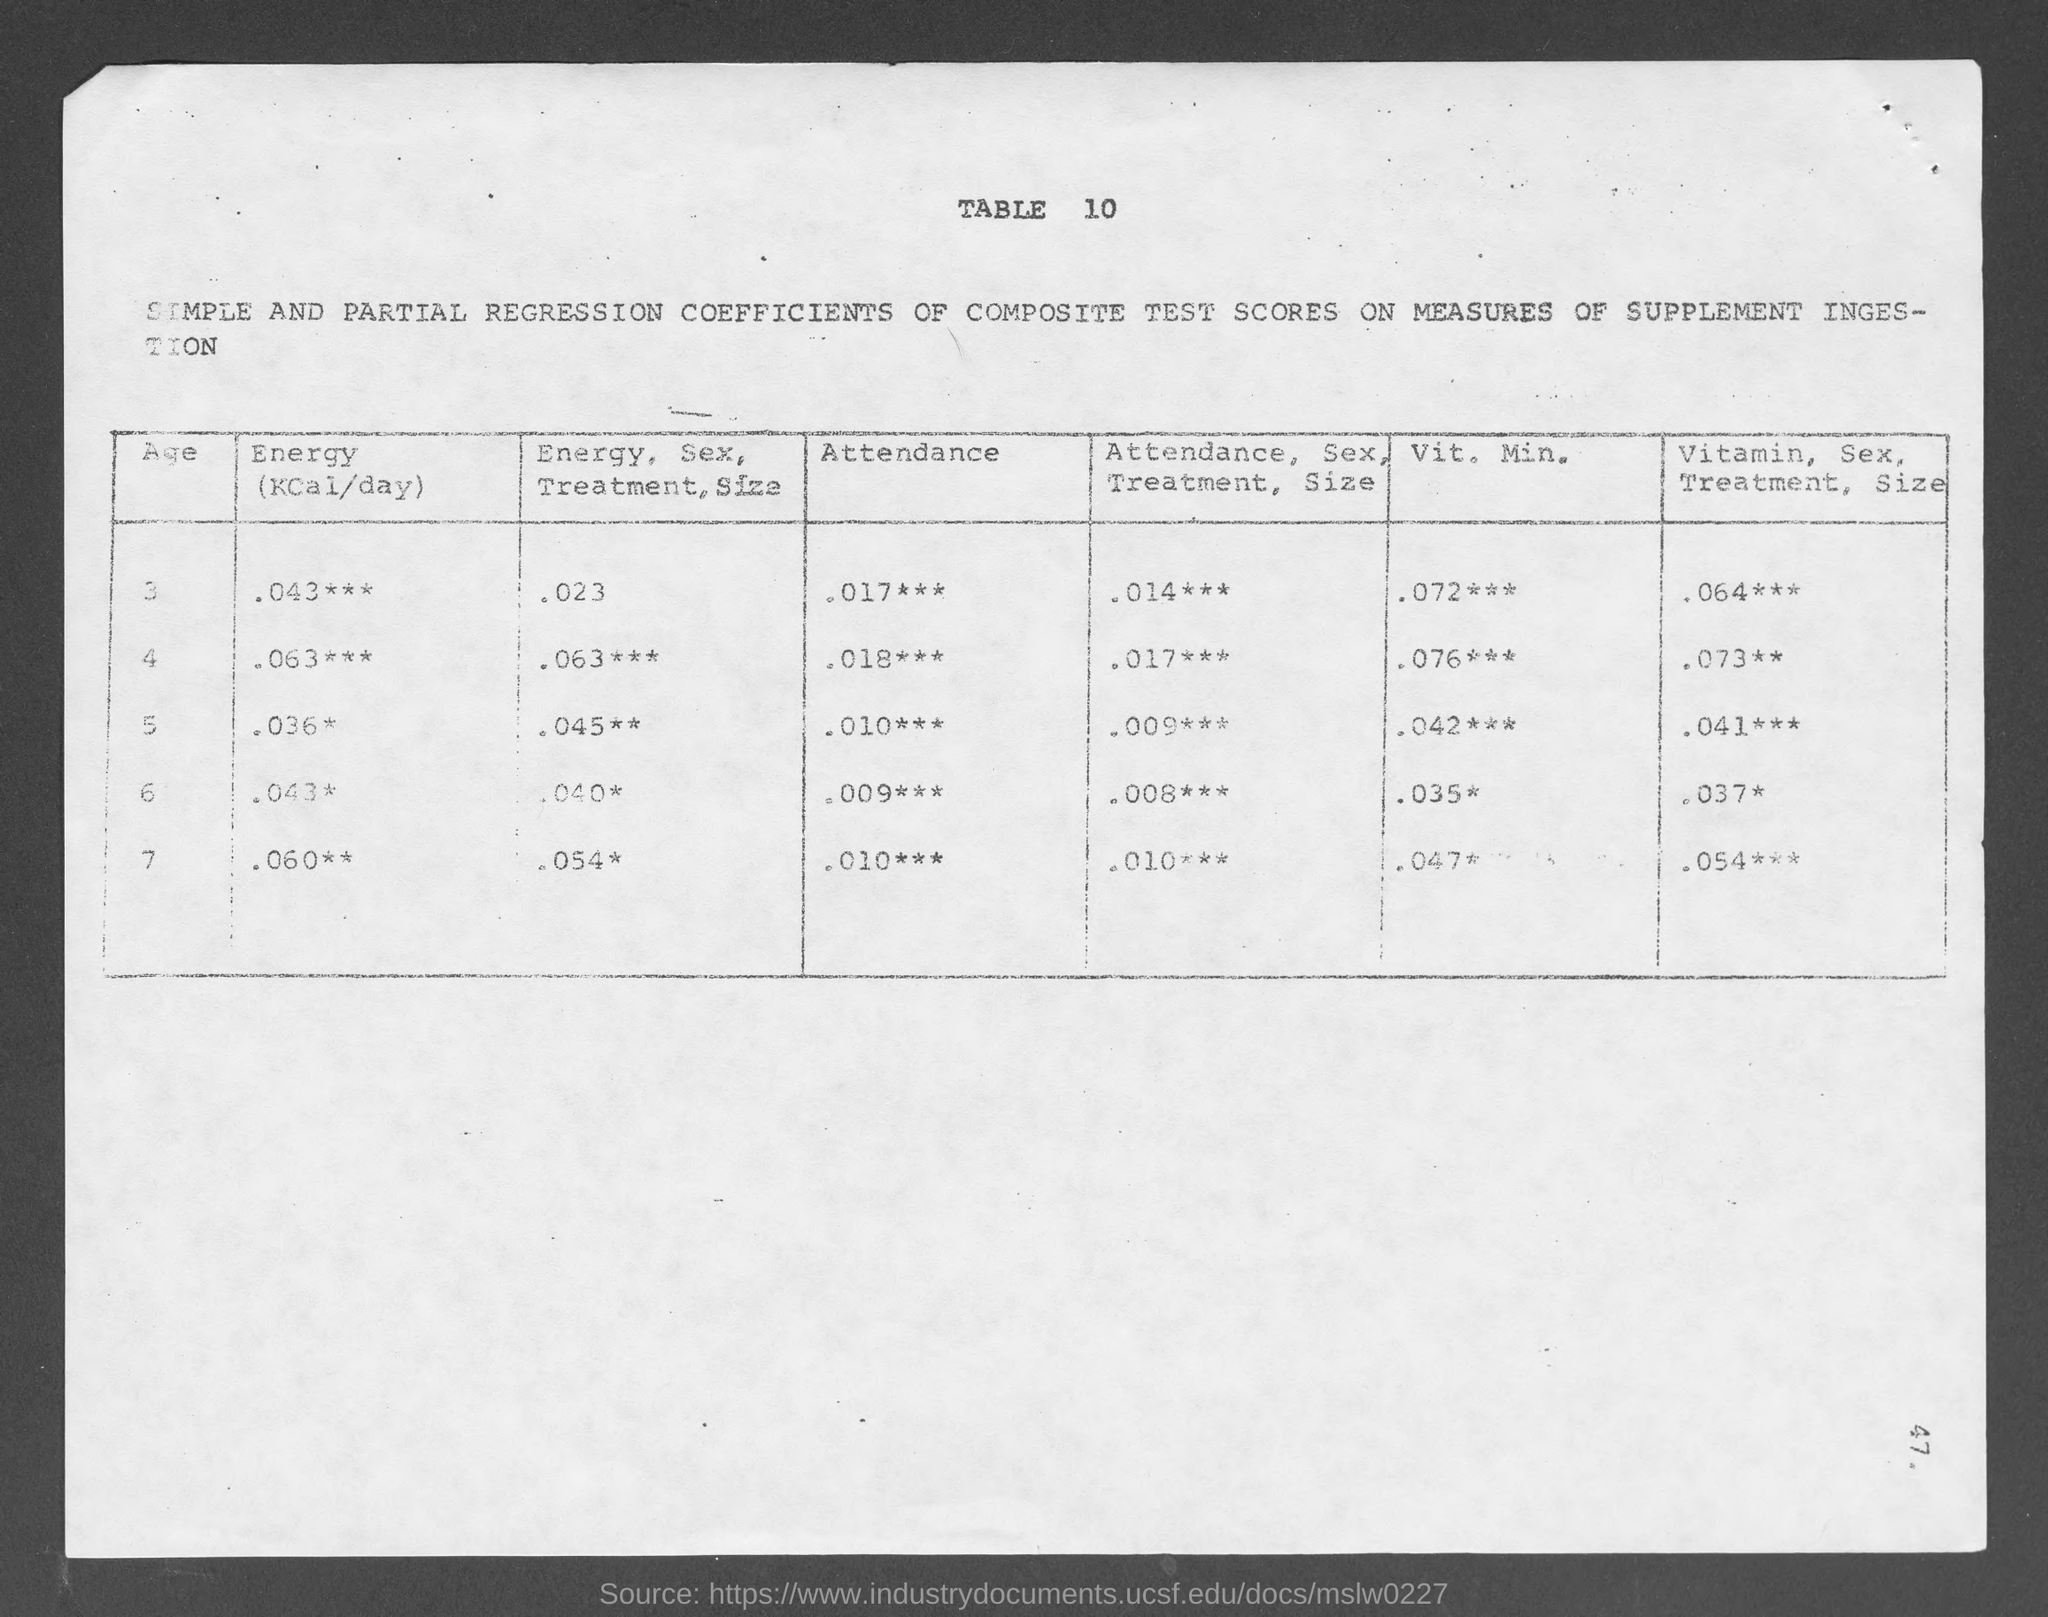Highlight a few significant elements in this photo. What is the table number?" is a question that requires a response. The amount of energy required for a child aged 3 is approximately 0.043 kilocalories per day. The amount of energy for a 6-year-old is approximately 0.43 kilocalories per day. The amount of energy for a child aged 4 is approximately 0.063 kilocalories (Kcal) per day. The amount of energy required for a child aged 5 is approximately 0.036 kilocalories per day. 